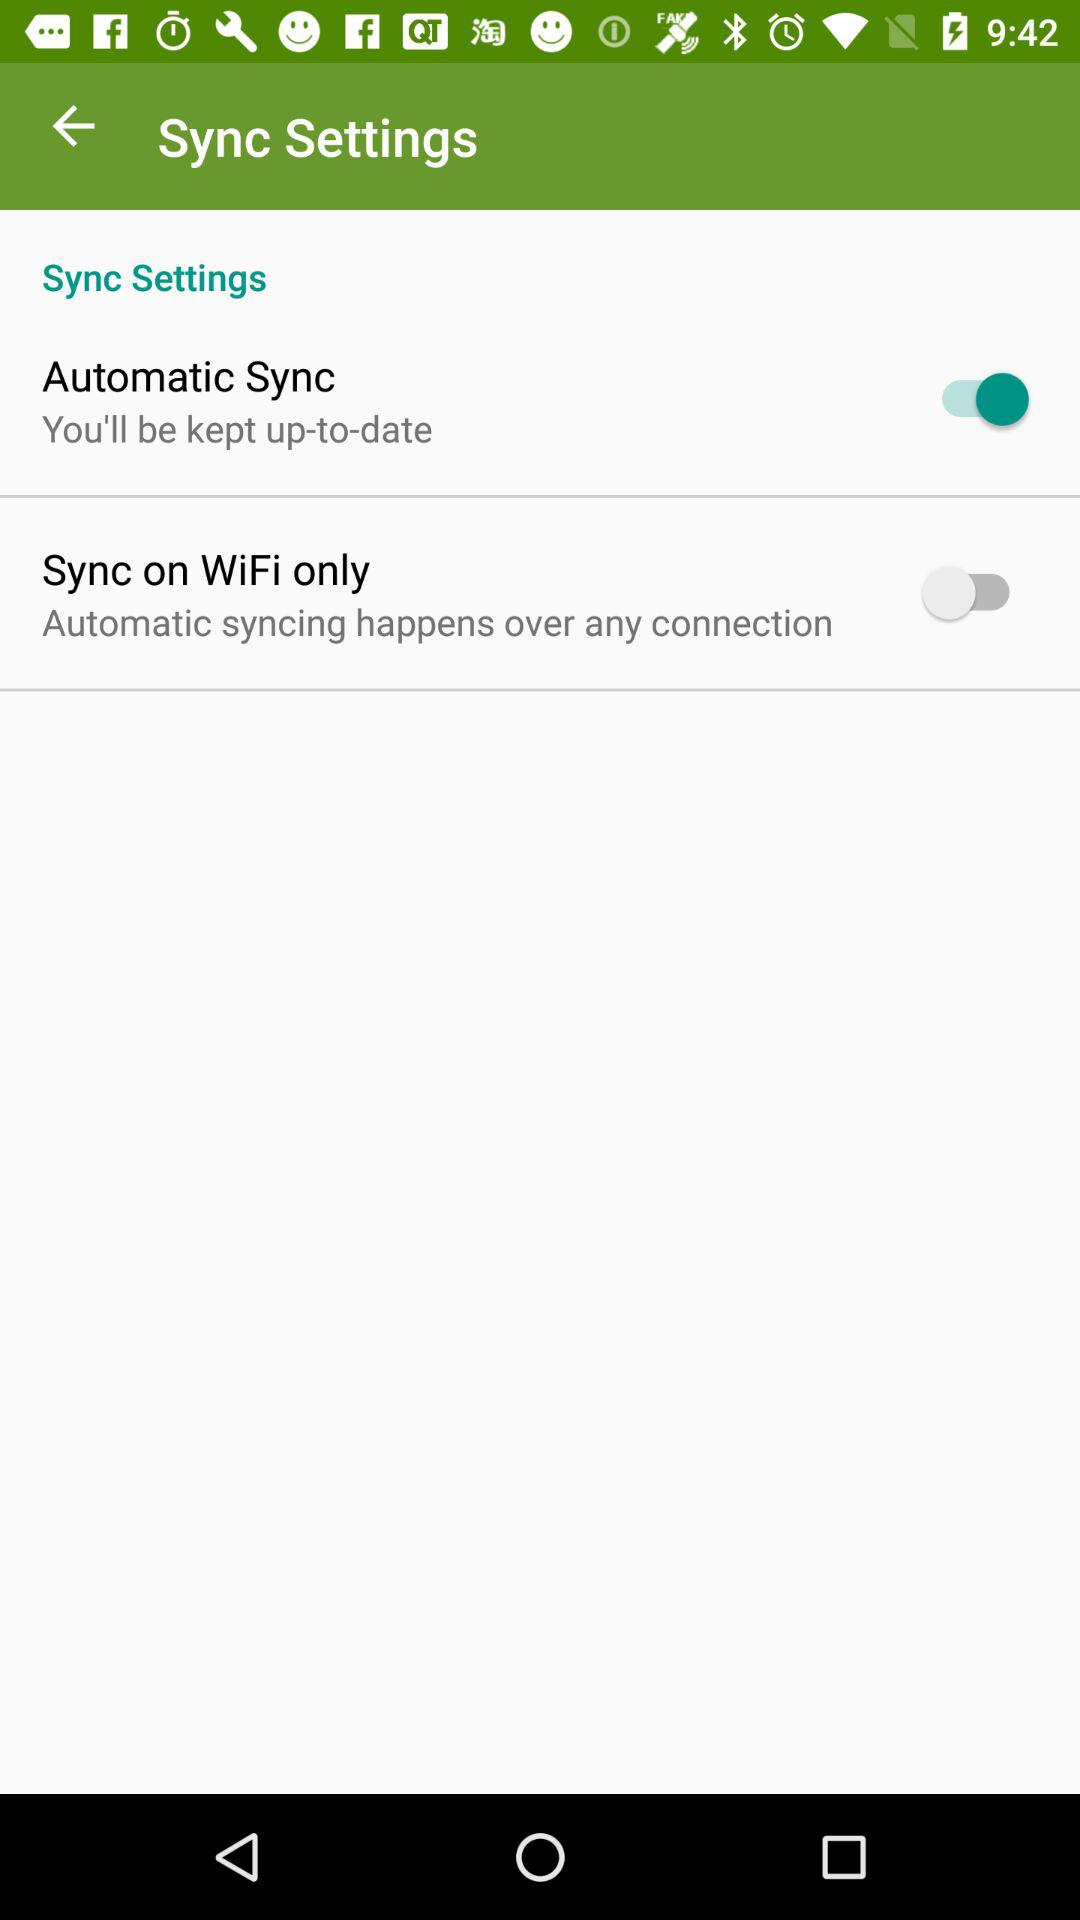What's the status of "Automatic Sync"? The status is "on". 